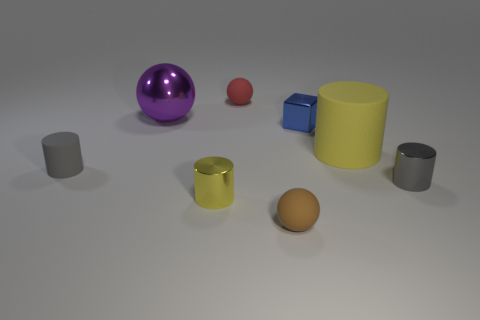Add 1 matte blocks. How many objects exist? 9 Subtract all cubes. How many objects are left? 7 Subtract 0 blue spheres. How many objects are left? 8 Subtract all gray shiny blocks. Subtract all big shiny spheres. How many objects are left? 7 Add 7 big purple things. How many big purple things are left? 8 Add 4 red matte things. How many red matte things exist? 5 